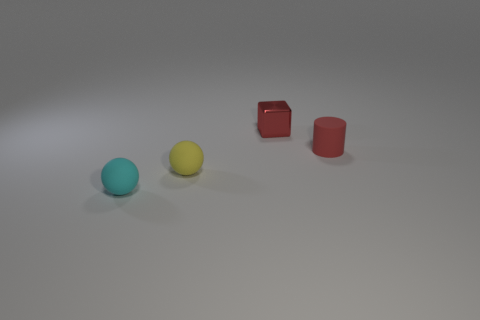Is there anything else that is the same shape as the red shiny thing?
Provide a succinct answer. No. There is a cube that is the same size as the red rubber cylinder; what material is it?
Your answer should be compact. Metal. There is a small yellow matte thing on the left side of the red metal thing; is it the same shape as the cyan object?
Your answer should be very brief. Yes. Are there more tiny cyan spheres in front of the tiny matte cylinder than rubber objects left of the tiny cyan ball?
Provide a succinct answer. Yes. How many spheres have the same material as the small yellow object?
Offer a terse response. 1. What is the color of the metal cube?
Keep it short and to the point. Red. How many objects are either yellow things or tiny brown blocks?
Your answer should be very brief. 1. Is there a small yellow metallic object that has the same shape as the tiny cyan object?
Provide a short and direct response. No. There is a thing that is on the right side of the red metallic cube; does it have the same color as the block?
Your response must be concise. Yes. There is a tiny thing that is in front of the matte ball behind the tiny cyan matte ball; what shape is it?
Provide a succinct answer. Sphere. 